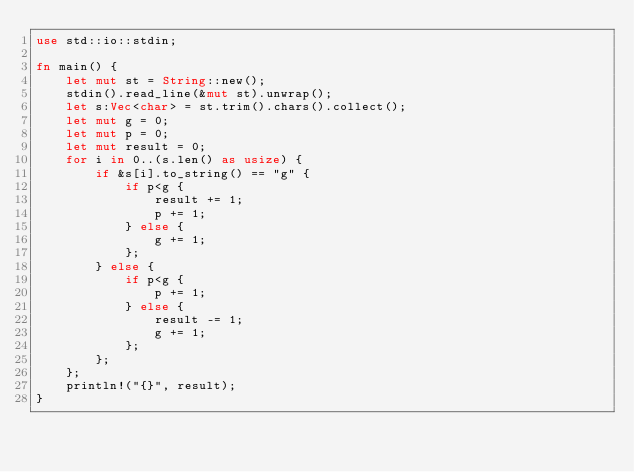<code> <loc_0><loc_0><loc_500><loc_500><_Rust_>use std::io::stdin;

fn main() {
    let mut st = String::new();
    stdin().read_line(&mut st).unwrap();
    let s:Vec<char> = st.trim().chars().collect();
    let mut g = 0;
    let mut p = 0;
    let mut result = 0;
    for i in 0..(s.len() as usize) {
        if &s[i].to_string() == "g" {
            if p<g {
                result += 1;
                p += 1;
            } else {
                g += 1;
            };
        } else {
            if p<g {
                p += 1;
            } else {
                result -= 1;
                g += 1;
            };
        };
    };
    println!("{}", result);
}</code> 